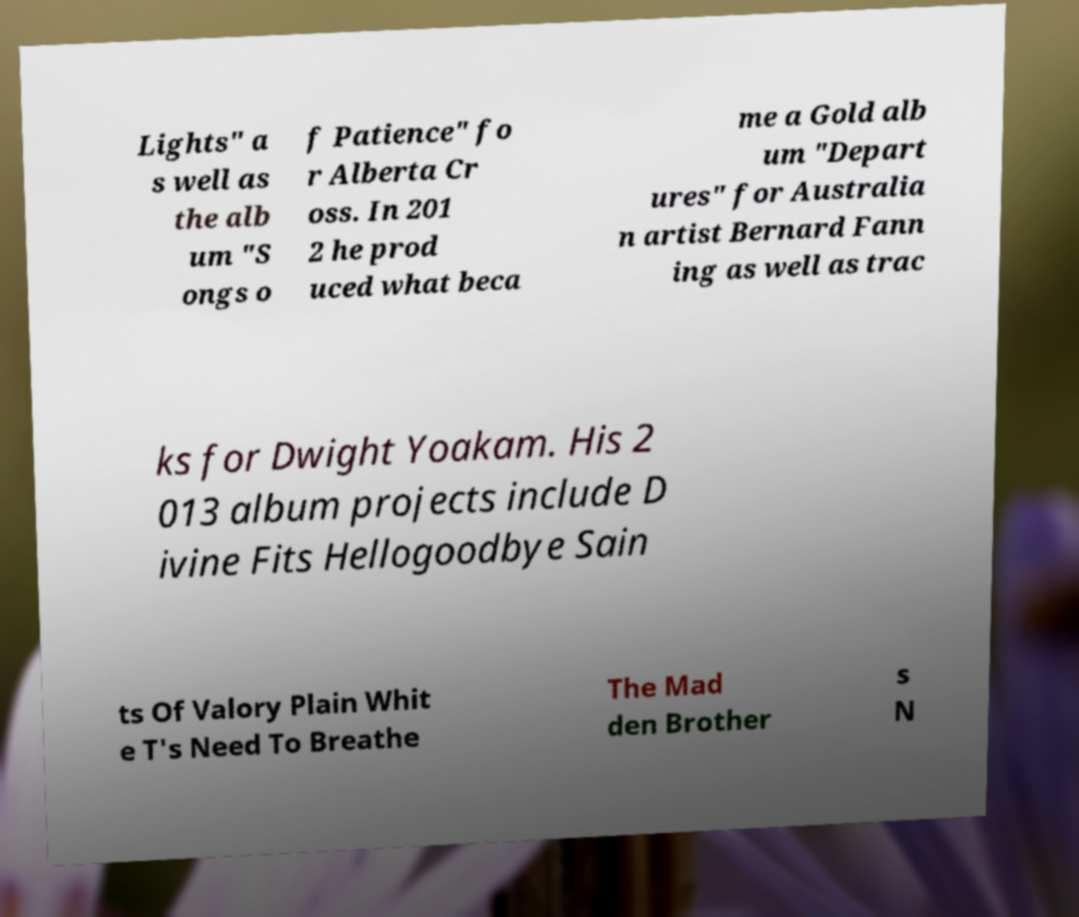What messages or text are displayed in this image? I need them in a readable, typed format. Lights" a s well as the alb um "S ongs o f Patience" fo r Alberta Cr oss. In 201 2 he prod uced what beca me a Gold alb um "Depart ures" for Australia n artist Bernard Fann ing as well as trac ks for Dwight Yoakam. His 2 013 album projects include D ivine Fits Hellogoodbye Sain ts Of Valory Plain Whit e T's Need To Breathe The Mad den Brother s N 